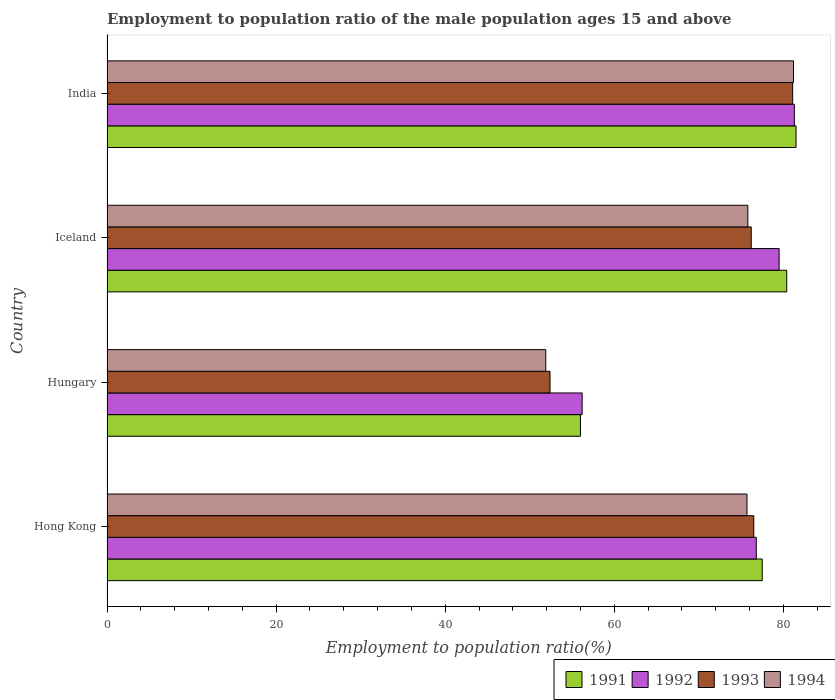Are the number of bars per tick equal to the number of legend labels?
Give a very brief answer. Yes. How many bars are there on the 2nd tick from the top?
Keep it short and to the point. 4. In how many cases, is the number of bars for a given country not equal to the number of legend labels?
Offer a very short reply. 0. What is the employment to population ratio in 1993 in Iceland?
Keep it short and to the point. 76.2. Across all countries, what is the maximum employment to population ratio in 1991?
Offer a terse response. 81.5. Across all countries, what is the minimum employment to population ratio in 1992?
Ensure brevity in your answer.  56.2. In which country was the employment to population ratio in 1991 maximum?
Offer a very short reply. India. In which country was the employment to population ratio in 1991 minimum?
Offer a very short reply. Hungary. What is the total employment to population ratio in 1993 in the graph?
Keep it short and to the point. 286.2. What is the difference between the employment to population ratio in 1992 in Hong Kong and that in Iceland?
Provide a short and direct response. -2.7. What is the difference between the employment to population ratio in 1991 in Iceland and the employment to population ratio in 1994 in Hong Kong?
Make the answer very short. 4.7. What is the average employment to population ratio in 1991 per country?
Ensure brevity in your answer.  73.85. What is the difference between the employment to population ratio in 1991 and employment to population ratio in 1993 in Iceland?
Your response must be concise. 4.2. In how many countries, is the employment to population ratio in 1993 greater than 40 %?
Provide a short and direct response. 4. What is the ratio of the employment to population ratio in 1993 in Hong Kong to that in Iceland?
Your response must be concise. 1. Is the employment to population ratio in 1994 in Iceland less than that in India?
Keep it short and to the point. Yes. What is the difference between the highest and the second highest employment to population ratio in 1994?
Provide a succinct answer. 5.4. What is the difference between the highest and the lowest employment to population ratio in 1992?
Make the answer very short. 25.1. What does the 2nd bar from the bottom in Iceland represents?
Keep it short and to the point. 1992. Is it the case that in every country, the sum of the employment to population ratio in 1991 and employment to population ratio in 1994 is greater than the employment to population ratio in 1992?
Provide a short and direct response. Yes. How many countries are there in the graph?
Make the answer very short. 4. Does the graph contain grids?
Your answer should be very brief. No. Where does the legend appear in the graph?
Your answer should be very brief. Bottom right. How many legend labels are there?
Ensure brevity in your answer.  4. How are the legend labels stacked?
Offer a very short reply. Horizontal. What is the title of the graph?
Keep it short and to the point. Employment to population ratio of the male population ages 15 and above. Does "2005" appear as one of the legend labels in the graph?
Keep it short and to the point. No. What is the label or title of the X-axis?
Offer a terse response. Employment to population ratio(%). What is the label or title of the Y-axis?
Offer a very short reply. Country. What is the Employment to population ratio(%) of 1991 in Hong Kong?
Offer a terse response. 77.5. What is the Employment to population ratio(%) of 1992 in Hong Kong?
Make the answer very short. 76.8. What is the Employment to population ratio(%) in 1993 in Hong Kong?
Your response must be concise. 76.5. What is the Employment to population ratio(%) of 1994 in Hong Kong?
Ensure brevity in your answer.  75.7. What is the Employment to population ratio(%) of 1991 in Hungary?
Give a very brief answer. 56. What is the Employment to population ratio(%) in 1992 in Hungary?
Your answer should be compact. 56.2. What is the Employment to population ratio(%) in 1993 in Hungary?
Offer a very short reply. 52.4. What is the Employment to population ratio(%) in 1994 in Hungary?
Your response must be concise. 51.9. What is the Employment to population ratio(%) of 1991 in Iceland?
Provide a short and direct response. 80.4. What is the Employment to population ratio(%) in 1992 in Iceland?
Give a very brief answer. 79.5. What is the Employment to population ratio(%) in 1993 in Iceland?
Offer a very short reply. 76.2. What is the Employment to population ratio(%) of 1994 in Iceland?
Provide a succinct answer. 75.8. What is the Employment to population ratio(%) of 1991 in India?
Your response must be concise. 81.5. What is the Employment to population ratio(%) in 1992 in India?
Offer a very short reply. 81.3. What is the Employment to population ratio(%) of 1993 in India?
Keep it short and to the point. 81.1. What is the Employment to population ratio(%) of 1994 in India?
Provide a succinct answer. 81.2. Across all countries, what is the maximum Employment to population ratio(%) of 1991?
Ensure brevity in your answer.  81.5. Across all countries, what is the maximum Employment to population ratio(%) of 1992?
Keep it short and to the point. 81.3. Across all countries, what is the maximum Employment to population ratio(%) in 1993?
Offer a terse response. 81.1. Across all countries, what is the maximum Employment to population ratio(%) of 1994?
Keep it short and to the point. 81.2. Across all countries, what is the minimum Employment to population ratio(%) of 1992?
Provide a short and direct response. 56.2. Across all countries, what is the minimum Employment to population ratio(%) in 1993?
Offer a very short reply. 52.4. Across all countries, what is the minimum Employment to population ratio(%) of 1994?
Your response must be concise. 51.9. What is the total Employment to population ratio(%) in 1991 in the graph?
Keep it short and to the point. 295.4. What is the total Employment to population ratio(%) in 1992 in the graph?
Offer a very short reply. 293.8. What is the total Employment to population ratio(%) in 1993 in the graph?
Offer a terse response. 286.2. What is the total Employment to population ratio(%) of 1994 in the graph?
Offer a very short reply. 284.6. What is the difference between the Employment to population ratio(%) in 1992 in Hong Kong and that in Hungary?
Ensure brevity in your answer.  20.6. What is the difference between the Employment to population ratio(%) of 1993 in Hong Kong and that in Hungary?
Offer a terse response. 24.1. What is the difference between the Employment to population ratio(%) of 1994 in Hong Kong and that in Hungary?
Your response must be concise. 23.8. What is the difference between the Employment to population ratio(%) in 1991 in Hong Kong and that in Iceland?
Keep it short and to the point. -2.9. What is the difference between the Employment to population ratio(%) of 1991 in Hong Kong and that in India?
Keep it short and to the point. -4. What is the difference between the Employment to population ratio(%) of 1991 in Hungary and that in Iceland?
Your answer should be compact. -24.4. What is the difference between the Employment to population ratio(%) in 1992 in Hungary and that in Iceland?
Make the answer very short. -23.3. What is the difference between the Employment to population ratio(%) of 1993 in Hungary and that in Iceland?
Provide a short and direct response. -23.8. What is the difference between the Employment to population ratio(%) of 1994 in Hungary and that in Iceland?
Your answer should be compact. -23.9. What is the difference between the Employment to population ratio(%) of 1991 in Hungary and that in India?
Provide a succinct answer. -25.5. What is the difference between the Employment to population ratio(%) in 1992 in Hungary and that in India?
Your response must be concise. -25.1. What is the difference between the Employment to population ratio(%) in 1993 in Hungary and that in India?
Make the answer very short. -28.7. What is the difference between the Employment to population ratio(%) of 1994 in Hungary and that in India?
Give a very brief answer. -29.3. What is the difference between the Employment to population ratio(%) in 1992 in Iceland and that in India?
Ensure brevity in your answer.  -1.8. What is the difference between the Employment to population ratio(%) of 1993 in Iceland and that in India?
Ensure brevity in your answer.  -4.9. What is the difference between the Employment to population ratio(%) in 1991 in Hong Kong and the Employment to population ratio(%) in 1992 in Hungary?
Give a very brief answer. 21.3. What is the difference between the Employment to population ratio(%) in 1991 in Hong Kong and the Employment to population ratio(%) in 1993 in Hungary?
Keep it short and to the point. 25.1. What is the difference between the Employment to population ratio(%) of 1991 in Hong Kong and the Employment to population ratio(%) of 1994 in Hungary?
Your response must be concise. 25.6. What is the difference between the Employment to population ratio(%) of 1992 in Hong Kong and the Employment to population ratio(%) of 1993 in Hungary?
Your answer should be very brief. 24.4. What is the difference between the Employment to population ratio(%) in 1992 in Hong Kong and the Employment to population ratio(%) in 1994 in Hungary?
Give a very brief answer. 24.9. What is the difference between the Employment to population ratio(%) in 1993 in Hong Kong and the Employment to population ratio(%) in 1994 in Hungary?
Your answer should be compact. 24.6. What is the difference between the Employment to population ratio(%) in 1991 in Hong Kong and the Employment to population ratio(%) in 1992 in Iceland?
Your answer should be compact. -2. What is the difference between the Employment to population ratio(%) of 1993 in Hong Kong and the Employment to population ratio(%) of 1994 in Iceland?
Give a very brief answer. 0.7. What is the difference between the Employment to population ratio(%) in 1991 in Hong Kong and the Employment to population ratio(%) in 1993 in India?
Provide a succinct answer. -3.6. What is the difference between the Employment to population ratio(%) of 1991 in Hong Kong and the Employment to population ratio(%) of 1994 in India?
Keep it short and to the point. -3.7. What is the difference between the Employment to population ratio(%) of 1992 in Hong Kong and the Employment to population ratio(%) of 1993 in India?
Make the answer very short. -4.3. What is the difference between the Employment to population ratio(%) of 1992 in Hong Kong and the Employment to population ratio(%) of 1994 in India?
Ensure brevity in your answer.  -4.4. What is the difference between the Employment to population ratio(%) in 1991 in Hungary and the Employment to population ratio(%) in 1992 in Iceland?
Keep it short and to the point. -23.5. What is the difference between the Employment to population ratio(%) of 1991 in Hungary and the Employment to population ratio(%) of 1993 in Iceland?
Your response must be concise. -20.2. What is the difference between the Employment to population ratio(%) in 1991 in Hungary and the Employment to population ratio(%) in 1994 in Iceland?
Your answer should be compact. -19.8. What is the difference between the Employment to population ratio(%) of 1992 in Hungary and the Employment to population ratio(%) of 1994 in Iceland?
Provide a succinct answer. -19.6. What is the difference between the Employment to population ratio(%) of 1993 in Hungary and the Employment to population ratio(%) of 1994 in Iceland?
Offer a terse response. -23.4. What is the difference between the Employment to population ratio(%) of 1991 in Hungary and the Employment to population ratio(%) of 1992 in India?
Your response must be concise. -25.3. What is the difference between the Employment to population ratio(%) of 1991 in Hungary and the Employment to population ratio(%) of 1993 in India?
Keep it short and to the point. -25.1. What is the difference between the Employment to population ratio(%) in 1991 in Hungary and the Employment to population ratio(%) in 1994 in India?
Keep it short and to the point. -25.2. What is the difference between the Employment to population ratio(%) in 1992 in Hungary and the Employment to population ratio(%) in 1993 in India?
Your answer should be compact. -24.9. What is the difference between the Employment to population ratio(%) in 1992 in Hungary and the Employment to population ratio(%) in 1994 in India?
Your answer should be compact. -25. What is the difference between the Employment to population ratio(%) in 1993 in Hungary and the Employment to population ratio(%) in 1994 in India?
Ensure brevity in your answer.  -28.8. What is the difference between the Employment to population ratio(%) in 1991 in Iceland and the Employment to population ratio(%) in 1992 in India?
Your answer should be compact. -0.9. What is the difference between the Employment to population ratio(%) in 1991 in Iceland and the Employment to population ratio(%) in 1994 in India?
Make the answer very short. -0.8. What is the difference between the Employment to population ratio(%) of 1992 in Iceland and the Employment to population ratio(%) of 1994 in India?
Your response must be concise. -1.7. What is the difference between the Employment to population ratio(%) in 1993 in Iceland and the Employment to population ratio(%) in 1994 in India?
Offer a terse response. -5. What is the average Employment to population ratio(%) of 1991 per country?
Ensure brevity in your answer.  73.85. What is the average Employment to population ratio(%) of 1992 per country?
Offer a terse response. 73.45. What is the average Employment to population ratio(%) of 1993 per country?
Offer a terse response. 71.55. What is the average Employment to population ratio(%) of 1994 per country?
Keep it short and to the point. 71.15. What is the difference between the Employment to population ratio(%) of 1991 and Employment to population ratio(%) of 1993 in Hong Kong?
Ensure brevity in your answer.  1. What is the difference between the Employment to population ratio(%) of 1992 and Employment to population ratio(%) of 1993 in Hong Kong?
Offer a very short reply. 0.3. What is the difference between the Employment to population ratio(%) in 1992 and Employment to population ratio(%) in 1994 in Hong Kong?
Give a very brief answer. 1.1. What is the difference between the Employment to population ratio(%) of 1991 and Employment to population ratio(%) of 1992 in Hungary?
Your answer should be compact. -0.2. What is the difference between the Employment to population ratio(%) of 1991 and Employment to population ratio(%) of 1994 in Hungary?
Provide a short and direct response. 4.1. What is the difference between the Employment to population ratio(%) of 1992 and Employment to population ratio(%) of 1993 in Hungary?
Offer a terse response. 3.8. What is the difference between the Employment to population ratio(%) in 1992 and Employment to population ratio(%) in 1994 in Hungary?
Offer a very short reply. 4.3. What is the difference between the Employment to population ratio(%) in 1993 and Employment to population ratio(%) in 1994 in Hungary?
Give a very brief answer. 0.5. What is the difference between the Employment to population ratio(%) of 1991 and Employment to population ratio(%) of 1992 in Iceland?
Your answer should be very brief. 0.9. What is the difference between the Employment to population ratio(%) of 1991 and Employment to population ratio(%) of 1994 in Iceland?
Your response must be concise. 4.6. What is the difference between the Employment to population ratio(%) of 1992 and Employment to population ratio(%) of 1993 in India?
Your answer should be compact. 0.2. What is the difference between the Employment to population ratio(%) of 1992 and Employment to population ratio(%) of 1994 in India?
Your answer should be very brief. 0.1. What is the ratio of the Employment to population ratio(%) of 1991 in Hong Kong to that in Hungary?
Give a very brief answer. 1.38. What is the ratio of the Employment to population ratio(%) in 1992 in Hong Kong to that in Hungary?
Offer a very short reply. 1.37. What is the ratio of the Employment to population ratio(%) in 1993 in Hong Kong to that in Hungary?
Keep it short and to the point. 1.46. What is the ratio of the Employment to population ratio(%) in 1994 in Hong Kong to that in Hungary?
Keep it short and to the point. 1.46. What is the ratio of the Employment to population ratio(%) of 1991 in Hong Kong to that in Iceland?
Offer a terse response. 0.96. What is the ratio of the Employment to population ratio(%) of 1993 in Hong Kong to that in Iceland?
Make the answer very short. 1. What is the ratio of the Employment to population ratio(%) of 1991 in Hong Kong to that in India?
Ensure brevity in your answer.  0.95. What is the ratio of the Employment to population ratio(%) of 1992 in Hong Kong to that in India?
Give a very brief answer. 0.94. What is the ratio of the Employment to population ratio(%) of 1993 in Hong Kong to that in India?
Keep it short and to the point. 0.94. What is the ratio of the Employment to population ratio(%) of 1994 in Hong Kong to that in India?
Give a very brief answer. 0.93. What is the ratio of the Employment to population ratio(%) in 1991 in Hungary to that in Iceland?
Give a very brief answer. 0.7. What is the ratio of the Employment to population ratio(%) in 1992 in Hungary to that in Iceland?
Your answer should be very brief. 0.71. What is the ratio of the Employment to population ratio(%) in 1993 in Hungary to that in Iceland?
Keep it short and to the point. 0.69. What is the ratio of the Employment to population ratio(%) of 1994 in Hungary to that in Iceland?
Offer a terse response. 0.68. What is the ratio of the Employment to population ratio(%) in 1991 in Hungary to that in India?
Your answer should be compact. 0.69. What is the ratio of the Employment to population ratio(%) of 1992 in Hungary to that in India?
Your answer should be very brief. 0.69. What is the ratio of the Employment to population ratio(%) in 1993 in Hungary to that in India?
Offer a terse response. 0.65. What is the ratio of the Employment to population ratio(%) of 1994 in Hungary to that in India?
Provide a short and direct response. 0.64. What is the ratio of the Employment to population ratio(%) of 1991 in Iceland to that in India?
Your answer should be very brief. 0.99. What is the ratio of the Employment to population ratio(%) in 1992 in Iceland to that in India?
Offer a very short reply. 0.98. What is the ratio of the Employment to population ratio(%) of 1993 in Iceland to that in India?
Your answer should be very brief. 0.94. What is the ratio of the Employment to population ratio(%) in 1994 in Iceland to that in India?
Your answer should be compact. 0.93. What is the difference between the highest and the second highest Employment to population ratio(%) in 1992?
Ensure brevity in your answer.  1.8. What is the difference between the highest and the second highest Employment to population ratio(%) of 1994?
Make the answer very short. 5.4. What is the difference between the highest and the lowest Employment to population ratio(%) of 1992?
Offer a very short reply. 25.1. What is the difference between the highest and the lowest Employment to population ratio(%) of 1993?
Offer a terse response. 28.7. What is the difference between the highest and the lowest Employment to population ratio(%) in 1994?
Your answer should be very brief. 29.3. 